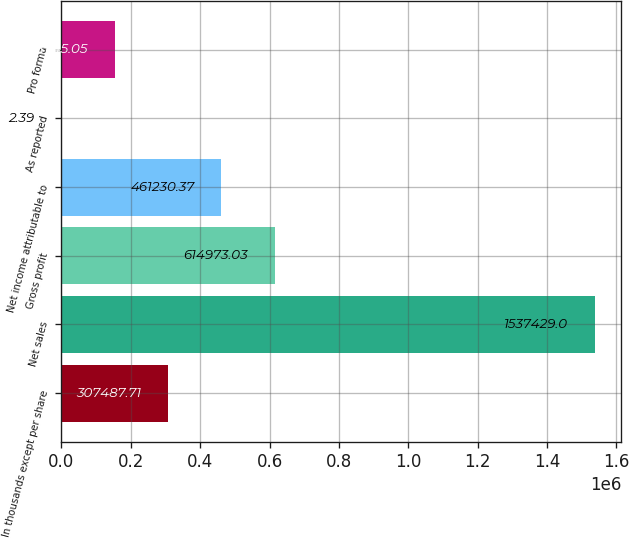<chart> <loc_0><loc_0><loc_500><loc_500><bar_chart><fcel>In thousands except per share<fcel>Net sales<fcel>Gross profit<fcel>Net income attributable to<fcel>As reported<fcel>Pro forma<nl><fcel>307488<fcel>1.53743e+06<fcel>614973<fcel>461230<fcel>2.39<fcel>153745<nl></chart> 